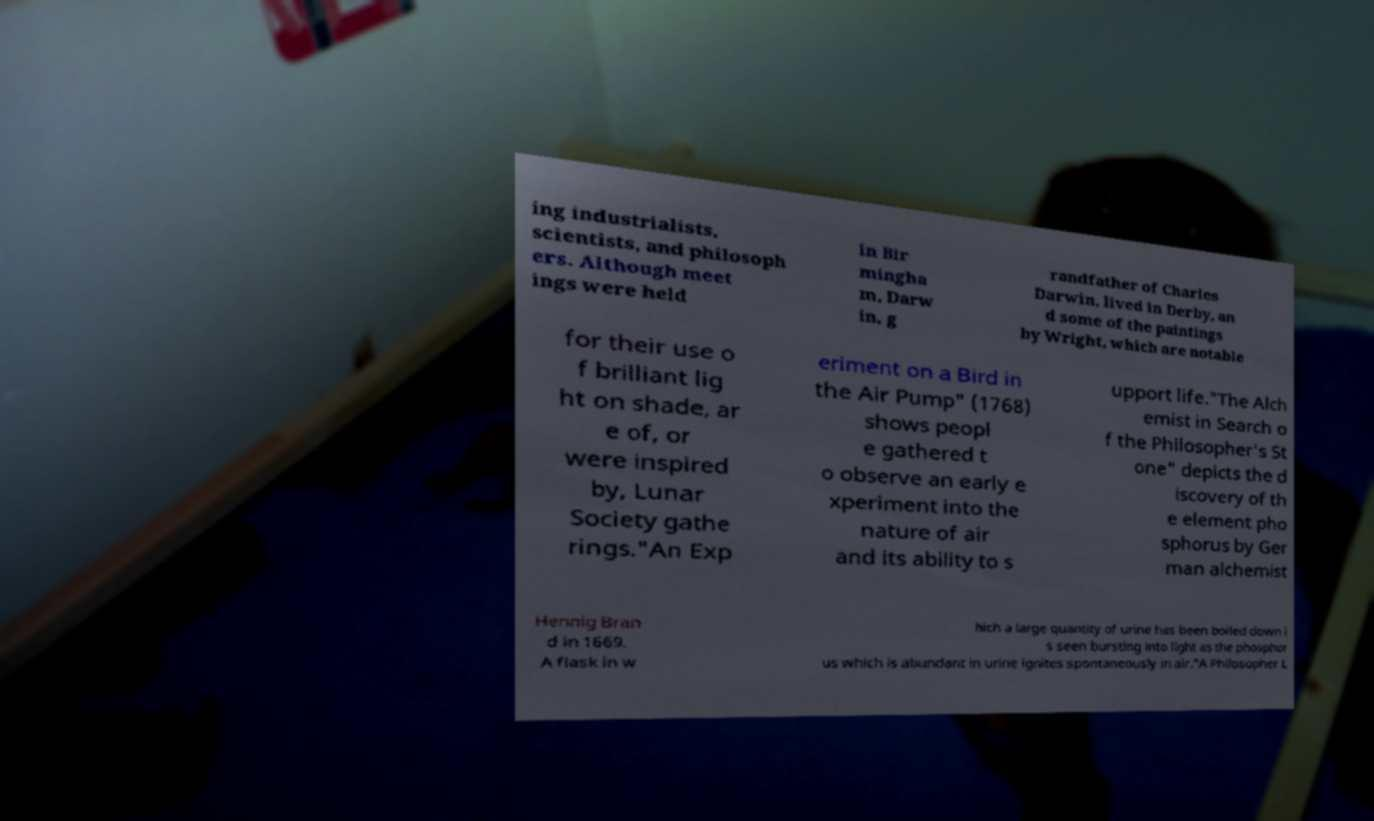There's text embedded in this image that I need extracted. Can you transcribe it verbatim? ing industrialists, scientists, and philosoph ers. Although meet ings were held in Bir mingha m, Darw in, g randfather of Charles Darwin, lived in Derby, an d some of the paintings by Wright, which are notable for their use o f brilliant lig ht on shade, ar e of, or were inspired by, Lunar Society gathe rings."An Exp eriment on a Bird in the Air Pump" (1768) shows peopl e gathered t o observe an early e xperiment into the nature of air and its ability to s upport life."The Alch emist in Search o f the Philosopher's St one" depicts the d iscovery of th e element pho sphorus by Ger man alchemist Hennig Bran d in 1669. A flask in w hich a large quantity of urine has been boiled down i s seen bursting into light as the phosphor us which is abundant in urine ignites spontaneously in air."A Philosopher L 